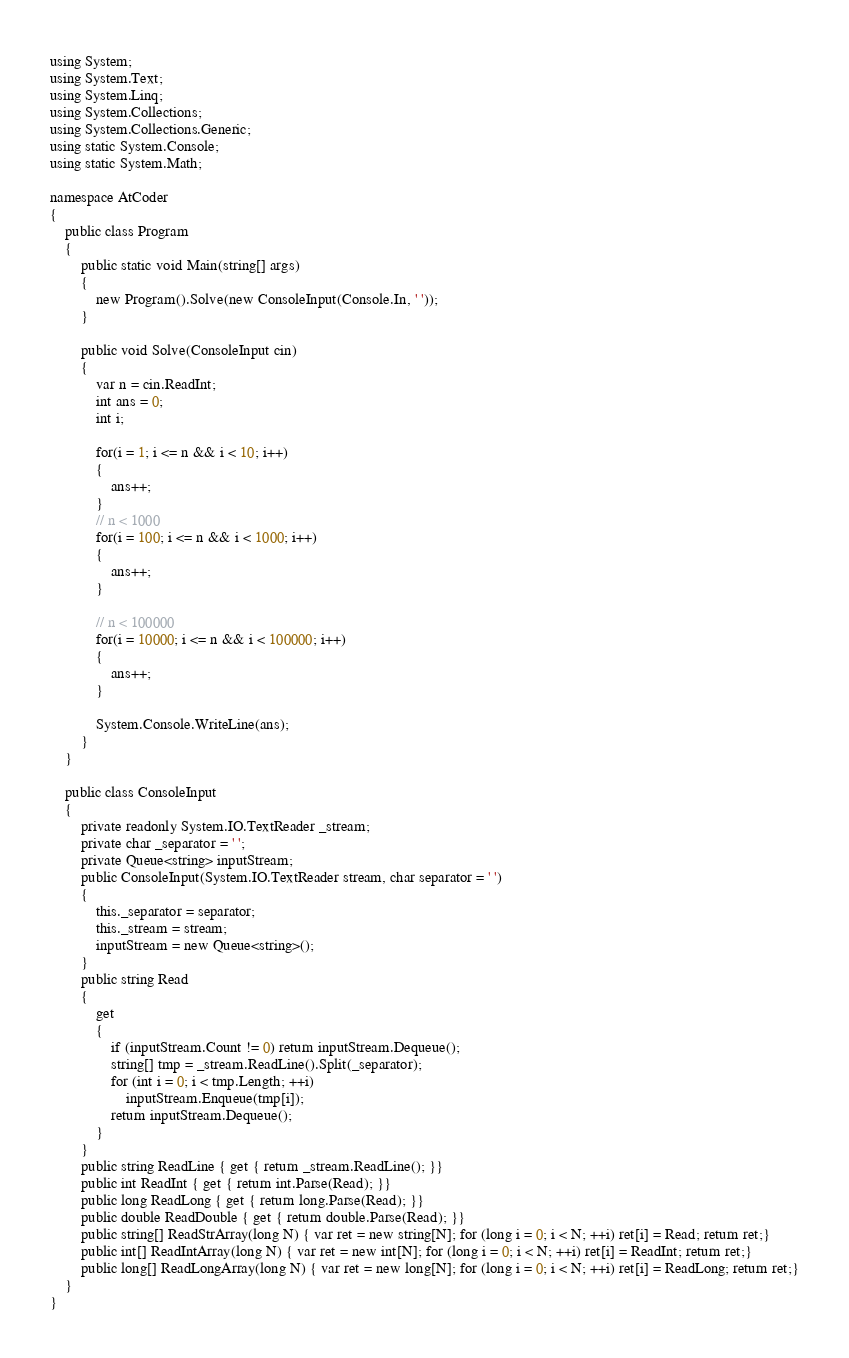Convert code to text. <code><loc_0><loc_0><loc_500><loc_500><_C#_>using System;
using System.Text;
using System.Linq;
using System.Collections;
using System.Collections.Generic;
using static System.Console;
using static System.Math;

namespace AtCoder
{
    public class Program
    {
        public static void Main(string[] args)
        {
            new Program().Solve(new ConsoleInput(Console.In, ' '));
        }

        public void Solve(ConsoleInput cin)
        {
            var n = cin.ReadInt;
            int ans = 0;
            int i;

            for(i = 1; i <= n && i < 10; i++)
            {
                ans++;
            }
            // n < 1000
            for(i = 100; i <= n && i < 1000; i++)
            {
                ans++;
            }

            // n < 100000
            for(i = 10000; i <= n && i < 100000; i++)
            {
                ans++;
            }

            System.Console.WriteLine(ans);
        }
    }

    public class ConsoleInput
    {
        private readonly System.IO.TextReader _stream;
        private char _separator = ' ';
        private Queue<string> inputStream;
        public ConsoleInput(System.IO.TextReader stream, char separator = ' ')
        {
            this._separator = separator;
            this._stream = stream;
            inputStream = new Queue<string>();
        }
        public string Read
        {
            get
            {
                if (inputStream.Count != 0) return inputStream.Dequeue();
                string[] tmp = _stream.ReadLine().Split(_separator);
                for (int i = 0; i < tmp.Length; ++i)
                    inputStream.Enqueue(tmp[i]);
                return inputStream.Dequeue();
            }
        }
        public string ReadLine { get { return _stream.ReadLine(); }}
        public int ReadInt { get { return int.Parse(Read); }}
        public long ReadLong { get { return long.Parse(Read); }}
        public double ReadDouble { get { return double.Parse(Read); }}
        public string[] ReadStrArray(long N) { var ret = new string[N]; for (long i = 0; i < N; ++i) ret[i] = Read; return ret;}
        public int[] ReadIntArray(long N) { var ret = new int[N]; for (long i = 0; i < N; ++i) ret[i] = ReadInt; return ret;}
        public long[] ReadLongArray(long N) { var ret = new long[N]; for (long i = 0; i < N; ++i) ret[i] = ReadLong; return ret;}
    }
}
</code> 